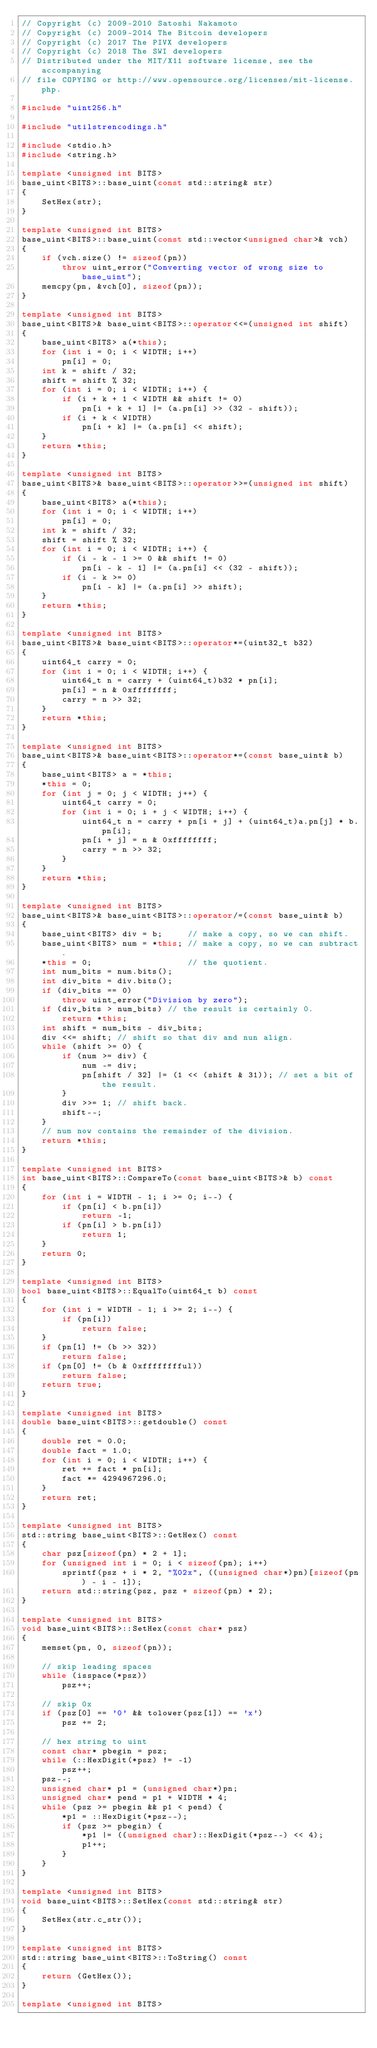Convert code to text. <code><loc_0><loc_0><loc_500><loc_500><_C++_>// Copyright (c) 2009-2010 Satoshi Nakamoto
// Copyright (c) 2009-2014 The Bitcoin developers
// Copyright (c) 2017 The PIVX developers
// Copyright (c) 2018 The SWI developers
// Distributed under the MIT/X11 software license, see the accompanying
// file COPYING or http://www.opensource.org/licenses/mit-license.php.

#include "uint256.h"

#include "utilstrencodings.h"

#include <stdio.h>
#include <string.h>

template <unsigned int BITS>
base_uint<BITS>::base_uint(const std::string& str)
{
    SetHex(str);
}

template <unsigned int BITS>
base_uint<BITS>::base_uint(const std::vector<unsigned char>& vch)
{
    if (vch.size() != sizeof(pn))
        throw uint_error("Converting vector of wrong size to base_uint");
    memcpy(pn, &vch[0], sizeof(pn));
}

template <unsigned int BITS>
base_uint<BITS>& base_uint<BITS>::operator<<=(unsigned int shift)
{
    base_uint<BITS> a(*this);
    for (int i = 0; i < WIDTH; i++)
        pn[i] = 0;
    int k = shift / 32;
    shift = shift % 32;
    for (int i = 0; i < WIDTH; i++) {
        if (i + k + 1 < WIDTH && shift != 0)
            pn[i + k + 1] |= (a.pn[i] >> (32 - shift));
        if (i + k < WIDTH)
            pn[i + k] |= (a.pn[i] << shift);
    }
    return *this;
}

template <unsigned int BITS>
base_uint<BITS>& base_uint<BITS>::operator>>=(unsigned int shift)
{
    base_uint<BITS> a(*this);
    for (int i = 0; i < WIDTH; i++)
        pn[i] = 0;
    int k = shift / 32;
    shift = shift % 32;
    for (int i = 0; i < WIDTH; i++) {
        if (i - k - 1 >= 0 && shift != 0)
            pn[i - k - 1] |= (a.pn[i] << (32 - shift));
        if (i - k >= 0)
            pn[i - k] |= (a.pn[i] >> shift);
    }
    return *this;
}

template <unsigned int BITS>
base_uint<BITS>& base_uint<BITS>::operator*=(uint32_t b32)
{
    uint64_t carry = 0;
    for (int i = 0; i < WIDTH; i++) {
        uint64_t n = carry + (uint64_t)b32 * pn[i];
        pn[i] = n & 0xffffffff;
        carry = n >> 32;
    }
    return *this;
}

template <unsigned int BITS>
base_uint<BITS>& base_uint<BITS>::operator*=(const base_uint& b)
{
    base_uint<BITS> a = *this;
    *this = 0;
    for (int j = 0; j < WIDTH; j++) {
        uint64_t carry = 0;
        for (int i = 0; i + j < WIDTH; i++) {
            uint64_t n = carry + pn[i + j] + (uint64_t)a.pn[j] * b.pn[i];
            pn[i + j] = n & 0xffffffff;
            carry = n >> 32;
        }
    }
    return *this;
}

template <unsigned int BITS>
base_uint<BITS>& base_uint<BITS>::operator/=(const base_uint& b)
{
    base_uint<BITS> div = b;     // make a copy, so we can shift.
    base_uint<BITS> num = *this; // make a copy, so we can subtract.
    *this = 0;                   // the quotient.
    int num_bits = num.bits();
    int div_bits = div.bits();
    if (div_bits == 0)
        throw uint_error("Division by zero");
    if (div_bits > num_bits) // the result is certainly 0.
        return *this;
    int shift = num_bits - div_bits;
    div <<= shift; // shift so that div and nun align.
    while (shift >= 0) {
        if (num >= div) {
            num -= div;
            pn[shift / 32] |= (1 << (shift & 31)); // set a bit of the result.
        }
        div >>= 1; // shift back.
        shift--;
    }
    // num now contains the remainder of the division.
    return *this;
}

template <unsigned int BITS>
int base_uint<BITS>::CompareTo(const base_uint<BITS>& b) const
{
    for (int i = WIDTH - 1; i >= 0; i--) {
        if (pn[i] < b.pn[i])
            return -1;
        if (pn[i] > b.pn[i])
            return 1;
    }
    return 0;
}

template <unsigned int BITS>
bool base_uint<BITS>::EqualTo(uint64_t b) const
{
    for (int i = WIDTH - 1; i >= 2; i--) {
        if (pn[i])
            return false;
    }
    if (pn[1] != (b >> 32))
        return false;
    if (pn[0] != (b & 0xfffffffful))
        return false;
    return true;
}

template <unsigned int BITS>
double base_uint<BITS>::getdouble() const
{
    double ret = 0.0;
    double fact = 1.0;
    for (int i = 0; i < WIDTH; i++) {
        ret += fact * pn[i];
        fact *= 4294967296.0;
    }
    return ret;
}

template <unsigned int BITS>
std::string base_uint<BITS>::GetHex() const
{
    char psz[sizeof(pn) * 2 + 1];
    for (unsigned int i = 0; i < sizeof(pn); i++)
        sprintf(psz + i * 2, "%02x", ((unsigned char*)pn)[sizeof(pn) - i - 1]);
    return std::string(psz, psz + sizeof(pn) * 2);
}

template <unsigned int BITS>
void base_uint<BITS>::SetHex(const char* psz)
{
    memset(pn, 0, sizeof(pn));

    // skip leading spaces
    while (isspace(*psz))
        psz++;

    // skip 0x
    if (psz[0] == '0' && tolower(psz[1]) == 'x')
        psz += 2;

    // hex string to uint
    const char* pbegin = psz;
    while (::HexDigit(*psz) != -1)
        psz++;
    psz--;
    unsigned char* p1 = (unsigned char*)pn;
    unsigned char* pend = p1 + WIDTH * 4;
    while (psz >= pbegin && p1 < pend) {
        *p1 = ::HexDigit(*psz--);
        if (psz >= pbegin) {
            *p1 |= ((unsigned char)::HexDigit(*psz--) << 4);
            p1++;
        }
    }
}

template <unsigned int BITS>
void base_uint<BITS>::SetHex(const std::string& str)
{
    SetHex(str.c_str());
}

template <unsigned int BITS>
std::string base_uint<BITS>::ToString() const
{
    return (GetHex());
}

template <unsigned int BITS></code> 